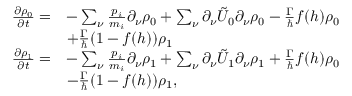<formula> <loc_0><loc_0><loc_500><loc_500>\begin{array} { r l } { \frac { \partial \rho _ { 0 } } { \partial t } = } & { - \sum _ { \nu } \frac { p _ { i } } { m _ { i } } \partial _ { \nu } \rho _ { 0 } + \sum _ { \nu } \partial _ { \nu } \tilde { U } _ { 0 } \partial _ { \nu } \rho _ { 0 } - \frac { \Gamma } { } f ( h ) \rho _ { 0 } } \\ & { + \frac { \Gamma } { } ( 1 - f ( h ) ) \rho _ { 1 } } \\ { \frac { \partial \rho _ { 1 } } { \partial t } = } & { - \sum _ { \nu } \frac { p _ { i } } { m _ { i } } \partial _ { \nu } \rho _ { 1 } + \sum _ { \nu } \partial _ { \nu } \tilde { U } _ { 1 } \partial _ { \nu } \rho _ { 1 } + \frac { \Gamma } { } f ( h ) \rho _ { 0 } } \\ & { - \frac { \Gamma } { } ( 1 - f ( h ) ) \rho _ { 1 } , } \end{array}</formula> 